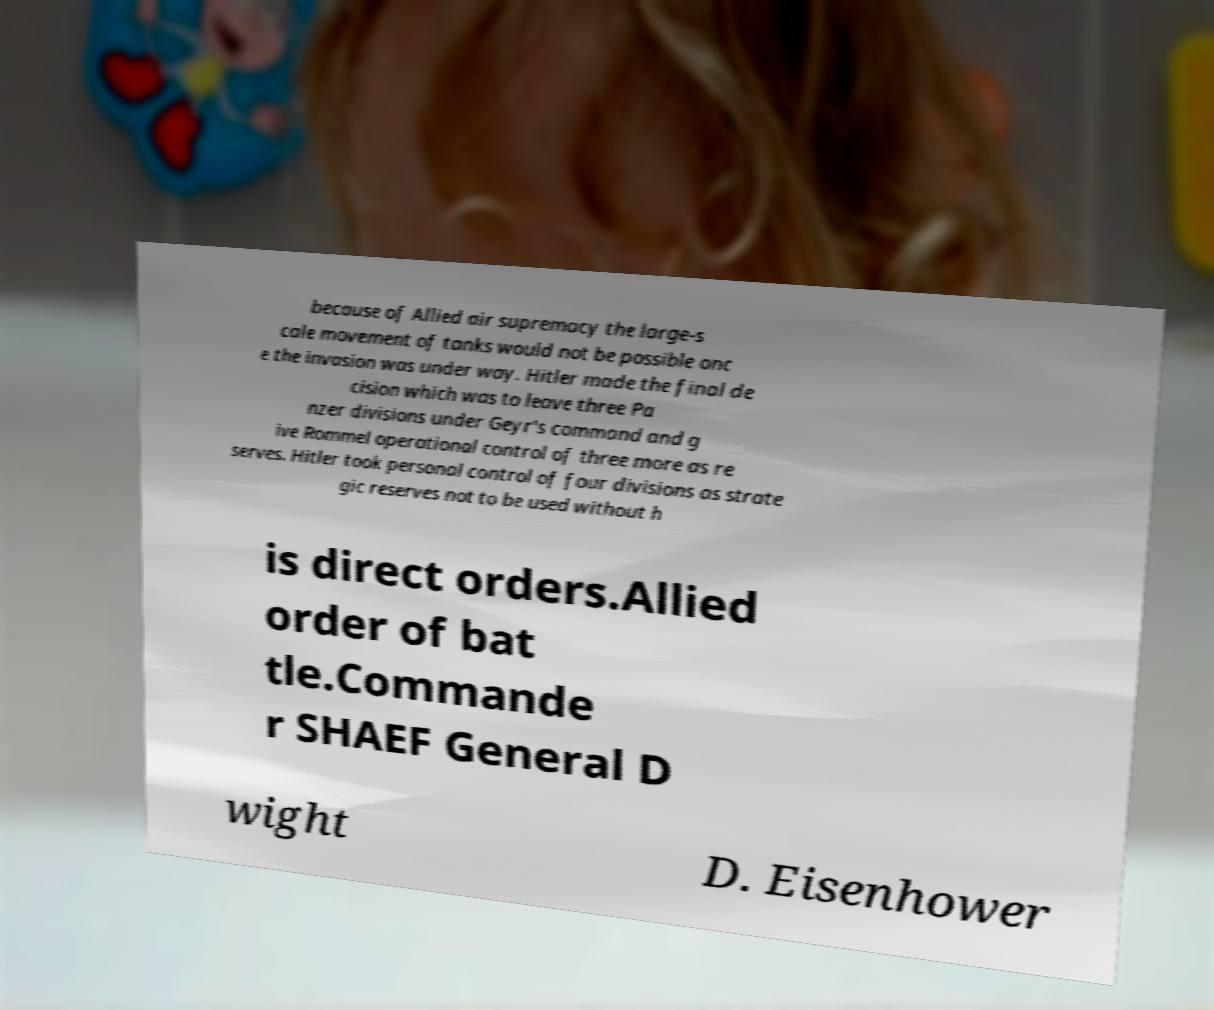Can you accurately transcribe the text from the provided image for me? because of Allied air supremacy the large-s cale movement of tanks would not be possible onc e the invasion was under way. Hitler made the final de cision which was to leave three Pa nzer divisions under Geyr's command and g ive Rommel operational control of three more as re serves. Hitler took personal control of four divisions as strate gic reserves not to be used without h is direct orders.Allied order of bat tle.Commande r SHAEF General D wight D. Eisenhower 